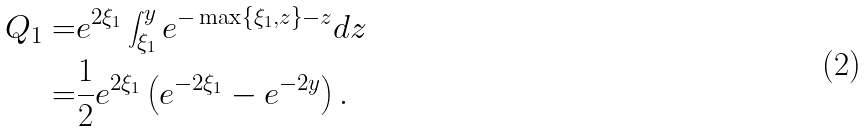<formula> <loc_0><loc_0><loc_500><loc_500>Q _ { 1 } = & e ^ { 2 \xi _ { 1 } } \int _ { \xi _ { 1 } } ^ { y } e ^ { - \max \left \{ \xi _ { 1 } , z \right \} - z } d z \\ = & \frac { 1 } { 2 } e ^ { 2 \xi _ { 1 } } \left ( e ^ { - 2 \xi _ { 1 } } - e ^ { - 2 y } \right ) .</formula> 